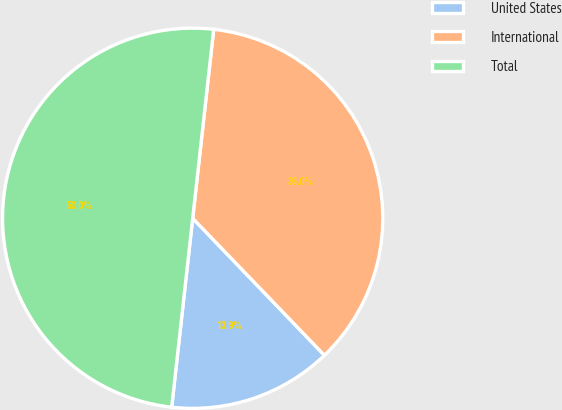Convert chart. <chart><loc_0><loc_0><loc_500><loc_500><pie_chart><fcel>United States<fcel>International<fcel>Total<nl><fcel>13.95%<fcel>36.05%<fcel>50.0%<nl></chart> 